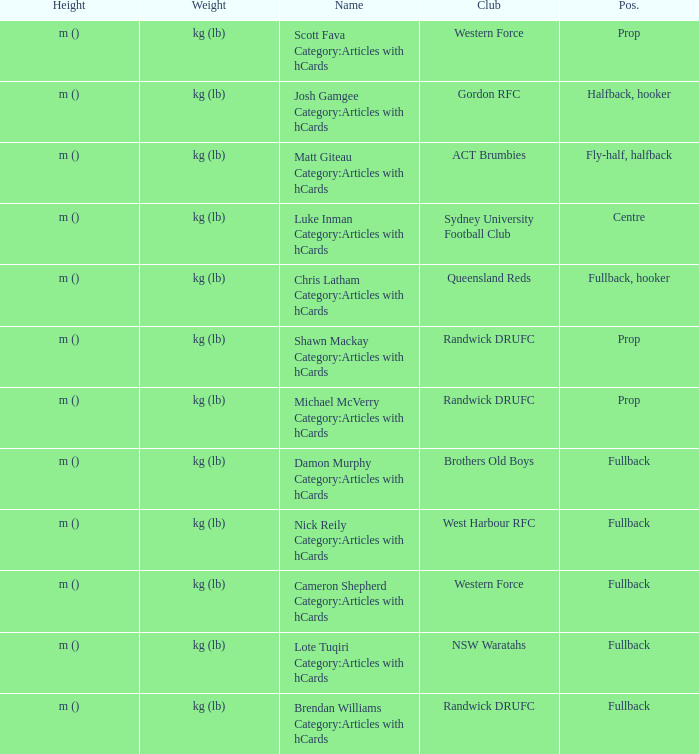What is the name when the position is centre? Luke Inman Category:Articles with hCards. 